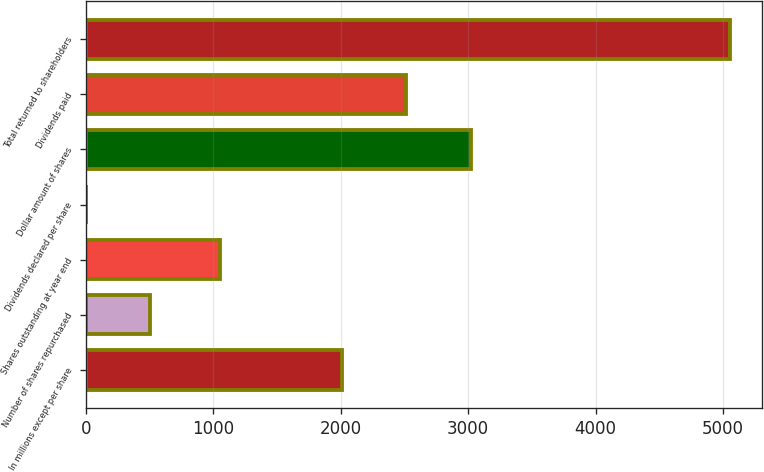Convert chart. <chart><loc_0><loc_0><loc_500><loc_500><bar_chart><fcel>In millions except per share<fcel>Number of shares repurchased<fcel>Shares outstanding at year end<fcel>Dividends declared per share<fcel>Dollar amount of shares<fcel>Dividends paid<fcel>Total returned to shareholders<nl><fcel>2010<fcel>507.73<fcel>1054<fcel>2.26<fcel>3020.94<fcel>2515.47<fcel>5057<nl></chart> 